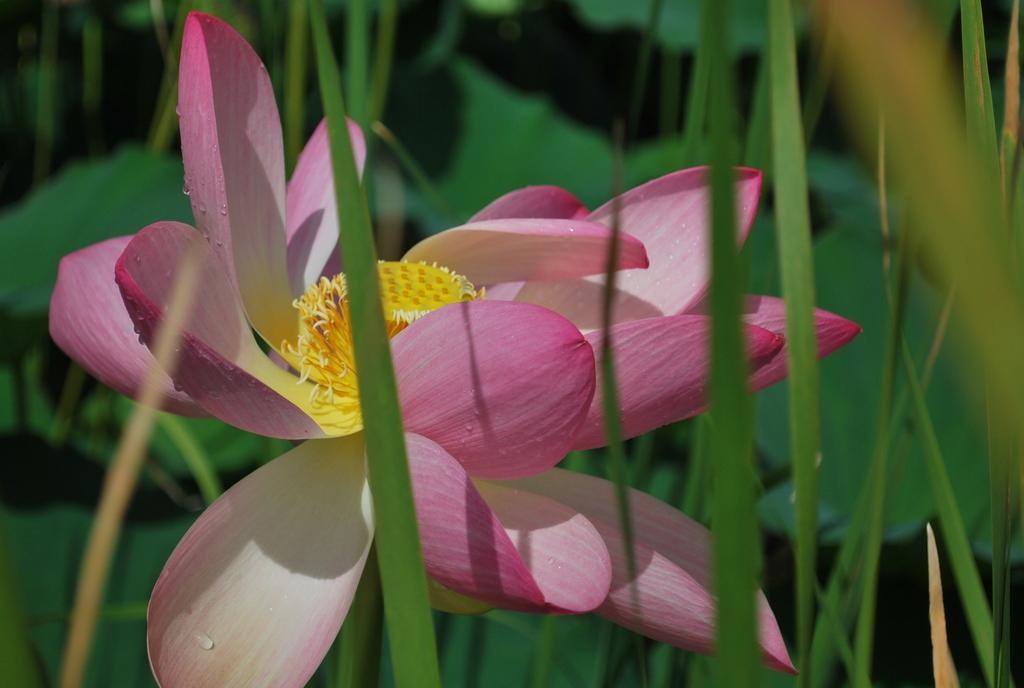What is the main subject of the image? There is a flower in the image. What can be seen in the background of the image? There is greenery in the background of the image. How many boys are holding the flower in the image? There are no boys present in the image; it features a flower and greenery in the background. What type of creature is interacting with the flower in the image? There is no creature interacting with the flower in the image; only the flower and greenery are present. 